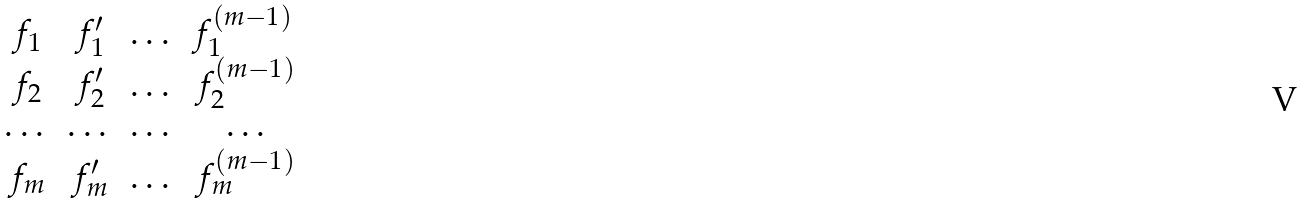<formula> <loc_0><loc_0><loc_500><loc_500>\begin{matrix} f _ { 1 } & f _ { 1 } ^ { \prime } & \dots & f _ { 1 } ^ { ( m - 1 ) } \, \\ f _ { 2 } & f _ { 2 } ^ { \prime } & \dots & f _ { 2 } ^ { ( m - 1 ) } \\ \dots & \dots & \dots & \dots \\ f _ { m } & f _ { m } ^ { \prime } & \dots & f _ { m } ^ { ( m - 1 ) } \end{matrix}</formula> 